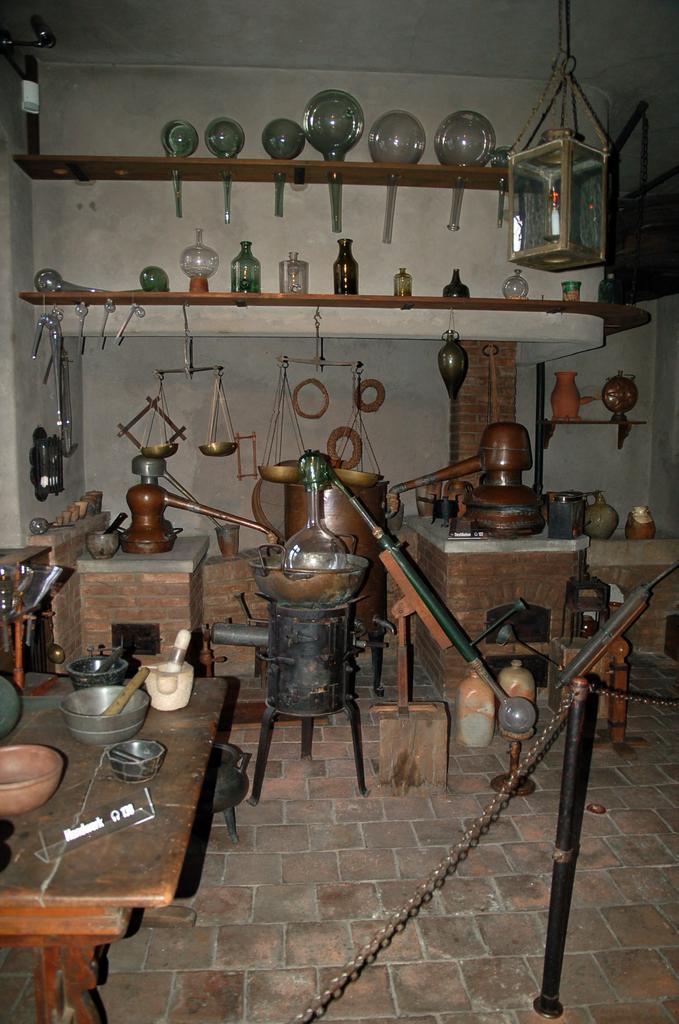Describe this image in one or two sentences. In this picture we can see a table on the left side, there are some bowls on the table, there are weighing balances and other things present in the middle, in the background there are two shelves, we can see some bottles and other things on these shelves, on the right side there is a glass box. 